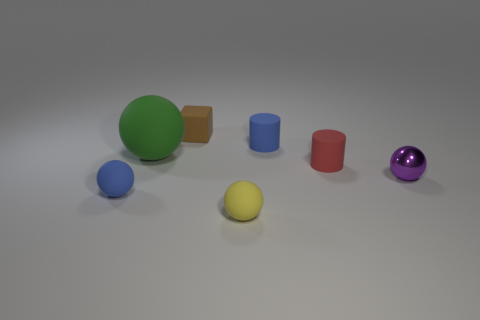Subtract all yellow cubes. Subtract all purple spheres. How many cubes are left? 1 Add 2 small shiny objects. How many objects exist? 9 Subtract all balls. How many objects are left? 3 Add 1 small purple objects. How many small purple objects exist? 2 Subtract 0 cyan cubes. How many objects are left? 7 Subtract all small purple metallic things. Subtract all small yellow rubber things. How many objects are left? 5 Add 1 green matte things. How many green matte things are left? 2 